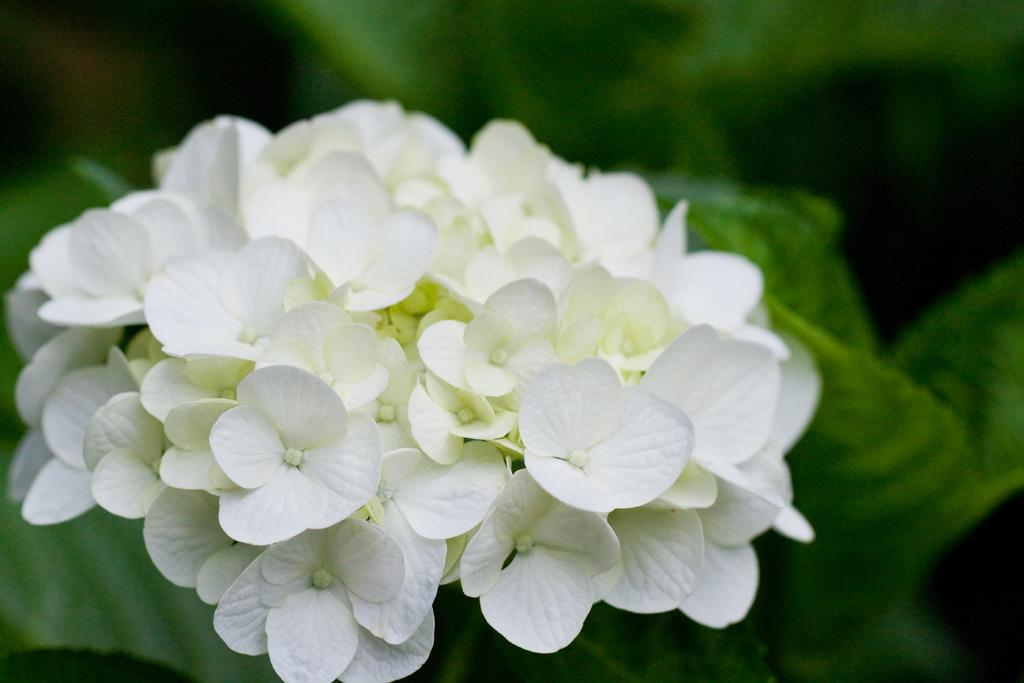What type of flowers are in the middle of the image? There are white color flowers in the middle of the image. What can be seen in the background of the image? There is greenery in the background of the image. What type of yarn is used to cover the body in the image? There is no yarn or body present in the image; it only features white color flowers and greenery in the background. 